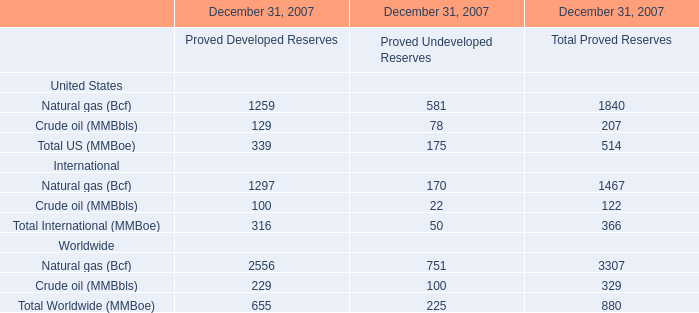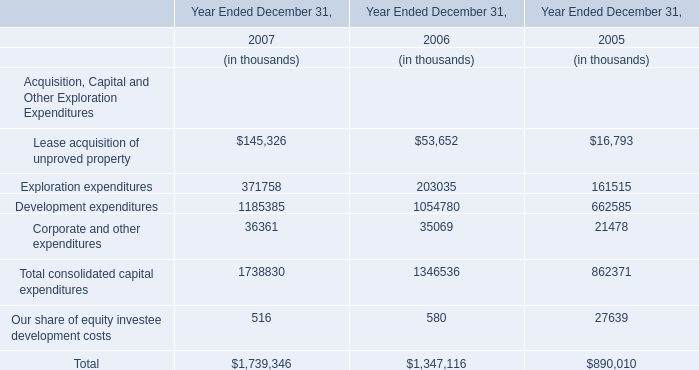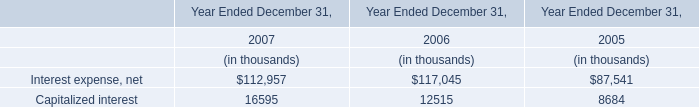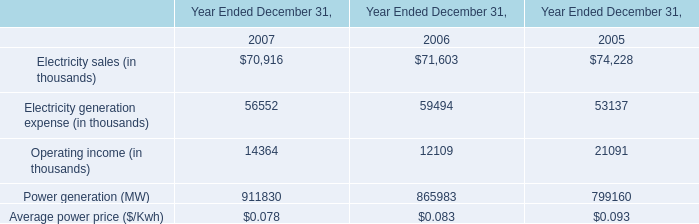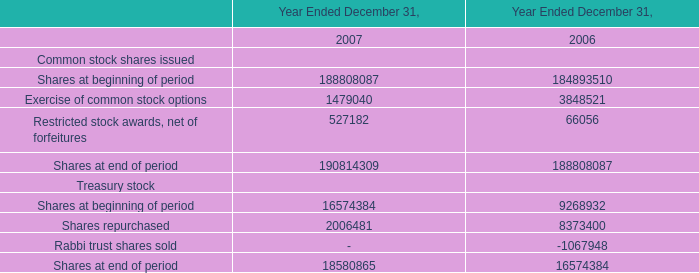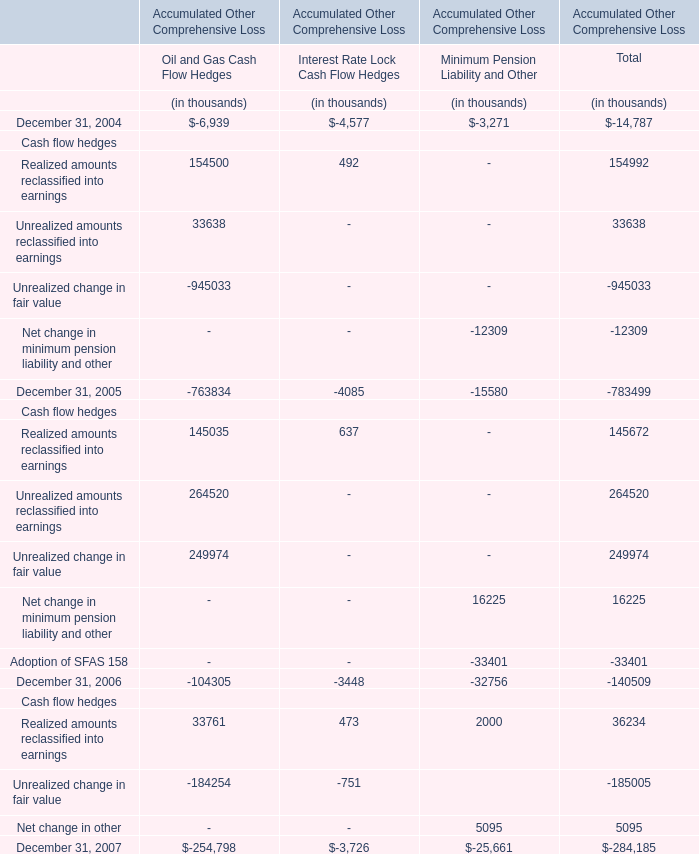Which year is Shares at beginning of period the highest? 
Answer: 2007. 